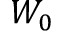Convert formula to latex. <formula><loc_0><loc_0><loc_500><loc_500>W _ { 0 }</formula> 